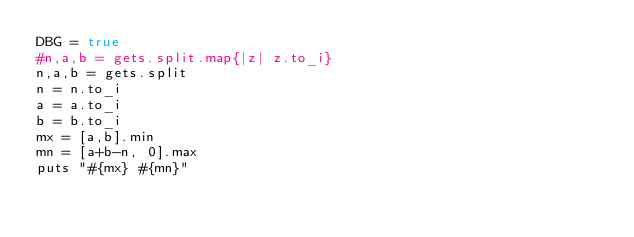<code> <loc_0><loc_0><loc_500><loc_500><_Ruby_>DBG = true
#n,a,b = gets.split.map{|z| z.to_i}
n,a,b = gets.split
n = n.to_i
a = a.to_i
b = b.to_i
mx = [a,b].min
mn = [a+b-n, 0].max
puts "#{mx} #{mn}"
</code> 